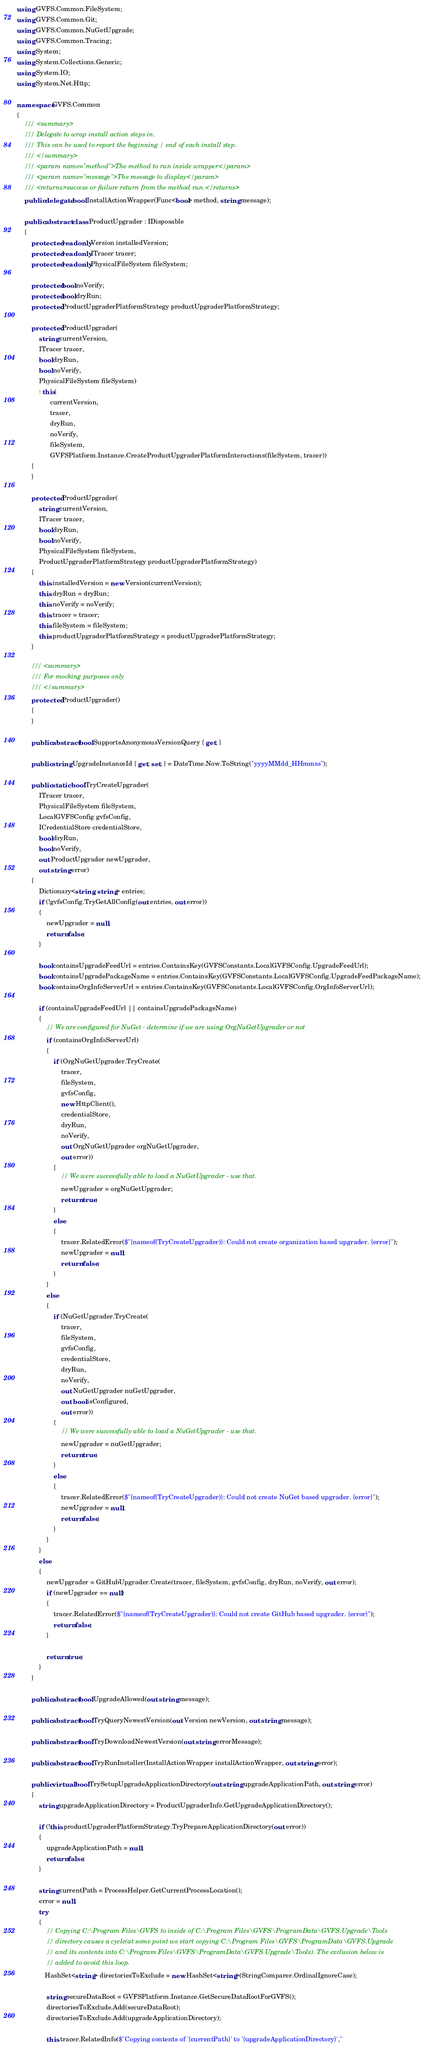Convert code to text. <code><loc_0><loc_0><loc_500><loc_500><_C#_>using GVFS.Common.FileSystem;
using GVFS.Common.Git;
using GVFS.Common.NuGetUpgrade;
using GVFS.Common.Tracing;
using System;
using System.Collections.Generic;
using System.IO;
using System.Net.Http;

namespace GVFS.Common
{
    /// <summary>
    /// Delegate to wrap install action steps in.
    /// This can be used to report the beginning / end of each install step.
    /// </summary>
    /// <param name="method">The method to run inside wrapper</param>
    /// <param name="message">The message to display</param>
    /// <returns>success or failure return from the method run.</returns>
    public delegate bool InstallActionWrapper(Func<bool> method, string message);

    public abstract class ProductUpgrader : IDisposable
    {
        protected readonly Version installedVersion;
        protected readonly ITracer tracer;
        protected readonly PhysicalFileSystem fileSystem;

        protected bool noVerify;
        protected bool dryRun;
        protected ProductUpgraderPlatformStrategy productUpgraderPlatformStrategy;

        protected ProductUpgrader(
            string currentVersion,
            ITracer tracer,
            bool dryRun,
            bool noVerify,
            PhysicalFileSystem fileSystem)
            : this(
                  currentVersion,
                  tracer,
                  dryRun,
                  noVerify,
                  fileSystem,
                  GVFSPlatform.Instance.CreateProductUpgraderPlatformInteractions(fileSystem, tracer))
        {
        }

        protected ProductUpgrader(
            string currentVersion,
            ITracer tracer,
            bool dryRun,
            bool noVerify,
            PhysicalFileSystem fileSystem,
            ProductUpgraderPlatformStrategy productUpgraderPlatformStrategy)
        {
            this.installedVersion = new Version(currentVersion);
            this.dryRun = dryRun;
            this.noVerify = noVerify;
            this.tracer = tracer;
            this.fileSystem = fileSystem;
            this.productUpgraderPlatformStrategy = productUpgraderPlatformStrategy;
        }

        /// <summary>
        /// For mocking purposes only
        /// </summary>
        protected ProductUpgrader()
        {
        }

        public abstract bool SupportsAnonymousVersionQuery { get; }

        public string UpgradeInstanceId { get; set; } = DateTime.Now.ToString("yyyyMMdd_HHmmss");

        public static bool TryCreateUpgrader(
            ITracer tracer,
            PhysicalFileSystem fileSystem,
            LocalGVFSConfig gvfsConfig,
            ICredentialStore credentialStore,
            bool dryRun,
            bool noVerify,
            out ProductUpgrader newUpgrader,
            out string error)
        {
            Dictionary<string, string> entries;
            if (!gvfsConfig.TryGetAllConfig(out entries, out error))
            {
                newUpgrader = null;
                return false;
            }

            bool containsUpgradeFeedUrl = entries.ContainsKey(GVFSConstants.LocalGVFSConfig.UpgradeFeedUrl);
            bool containsUpgradePackageName = entries.ContainsKey(GVFSConstants.LocalGVFSConfig.UpgradeFeedPackageName);
            bool containsOrgInfoServerUrl = entries.ContainsKey(GVFSConstants.LocalGVFSConfig.OrgInfoServerUrl);

            if (containsUpgradeFeedUrl || containsUpgradePackageName)
            {
                // We are configured for NuGet - determine if we are using OrgNuGetUpgrader or not
                if (containsOrgInfoServerUrl)
                {
                    if (OrgNuGetUpgrader.TryCreate(
                        tracer,
                        fileSystem,
                        gvfsConfig,
                        new HttpClient(),
                        credentialStore,
                        dryRun,
                        noVerify,
                        out OrgNuGetUpgrader orgNuGetUpgrader,
                        out error))
                    {
                        // We were successfully able to load a NuGetUpgrader - use that.
                        newUpgrader = orgNuGetUpgrader;
                        return true;
                    }
                    else
                    {
                        tracer.RelatedError($"{nameof(TryCreateUpgrader)}: Could not create organization based upgrader. {error}");
                        newUpgrader = null;
                        return false;
                    }
                }
                else
                {
                    if (NuGetUpgrader.TryCreate(
                        tracer,
                        fileSystem,
                        gvfsConfig,
                        credentialStore,
                        dryRun,
                        noVerify,
                        out NuGetUpgrader nuGetUpgrader,
                        out bool isConfigured,
                        out error))
                    {
                        // We were successfully able to load a NuGetUpgrader - use that.
                        newUpgrader = nuGetUpgrader;
                        return true;
                    }
                    else
                    {
                        tracer.RelatedError($"{nameof(TryCreateUpgrader)}: Could not create NuGet based upgrader. {error}");
                        newUpgrader = null;
                        return false;
                    }
                }
            }
            else
            {
                newUpgrader = GitHubUpgrader.Create(tracer, fileSystem, gvfsConfig, dryRun, noVerify, out error);
                if (newUpgrader == null)
                {
                    tracer.RelatedError($"{nameof(TryCreateUpgrader)}: Could not create GitHub based upgrader. {error}");
                    return false;
                }

                return true;
            }
        }

        public abstract bool UpgradeAllowed(out string message);

        public abstract bool TryQueryNewestVersion(out Version newVersion, out string message);

        public abstract bool TryDownloadNewestVersion(out string errorMessage);

        public abstract bool TryRunInstaller(InstallActionWrapper installActionWrapper, out string error);

        public virtual bool TrySetupUpgradeApplicationDirectory(out string upgradeApplicationPath, out string error)
        {
            string upgradeApplicationDirectory = ProductUpgraderInfo.GetUpgradeApplicationDirectory();

            if (!this.productUpgraderPlatformStrategy.TryPrepareApplicationDirectory(out error))
            {
                upgradeApplicationPath = null;
                return false;
            }

            string currentPath = ProcessHelper.GetCurrentProcessLocation();
            error = null;
            try
            {
                // Copying C:\Program Files\GVFS to inside of C:\Program Files\GVFS\ProgramData\GVFS.Upgrade\Tools
                // directory causes a cycle(at some point we start copying C:\Program Files\GVFS\ProgramData\GVFS.Upgrade
                // and its contents into C:\Program Files\GVFS\ProgramData\GVFS.Upgrade\Tools). The exclusion below is
                // added to avoid this loop.
               HashSet<string> directoriesToExclude = new HashSet<string>(StringComparer.OrdinalIgnoreCase);

                string secureDataRoot = GVFSPlatform.Instance.GetSecureDataRootForGVFS();
                directoriesToExclude.Add(secureDataRoot);
                directoriesToExclude.Add(upgradeApplicationDirectory);

                this.tracer.RelatedInfo($"Copying contents of '{currentPath}' to '{upgradeApplicationDirectory}',"</code> 